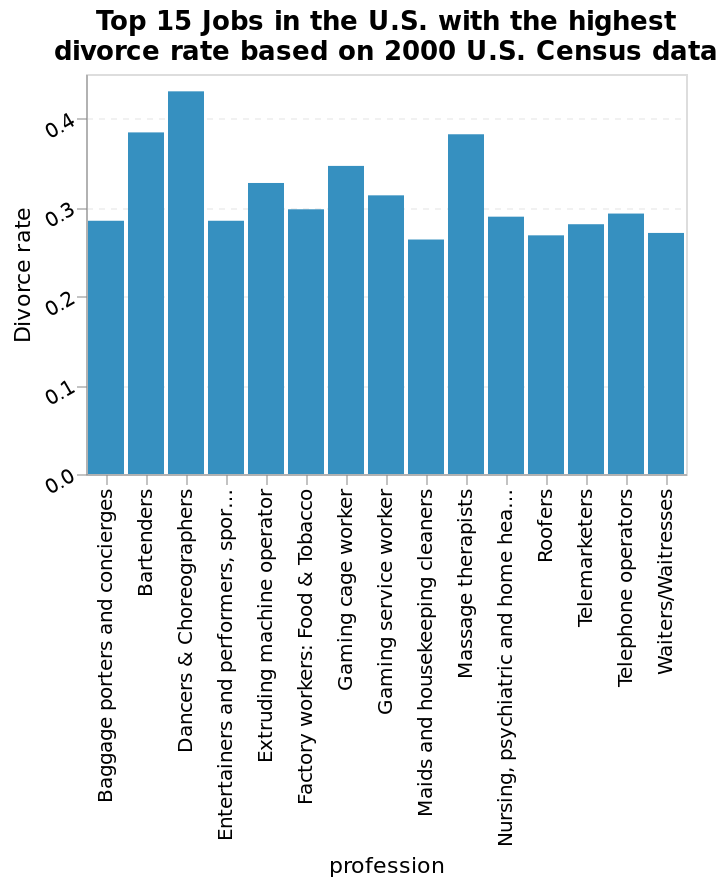<image>
please enumerates aspects of the construction of the chart Top 15 Jobs in the U.S. with the highest divorce rate based on 2000 U.S. Census data is a bar chart. Divorce rate is drawn using a linear scale from 0.0 to 0.4 on the y-axis. There is a categorical scale with Baggage porters and concierges on one end and Waiters/Waitresses at the other along the x-axis, labeled profession. What data source was used to create the bar chart? The 2000 U.S. Census data was used to create the bar chart. What information does the bar chart display about the professions? The bar chart displays the divorce rate for the top 15 jobs in the U.S., with the highest divorce rate. 